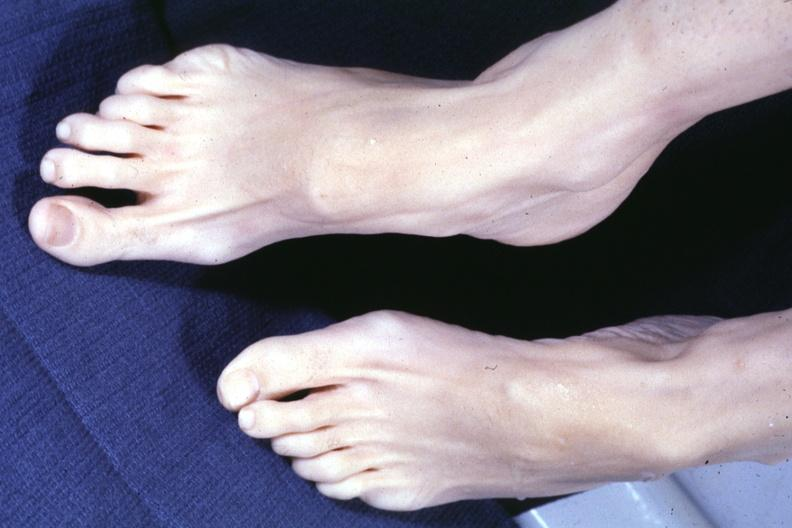what do no cystic aortic lesions see?
Answer the question using a single word or phrase. Other slide this interesting case 